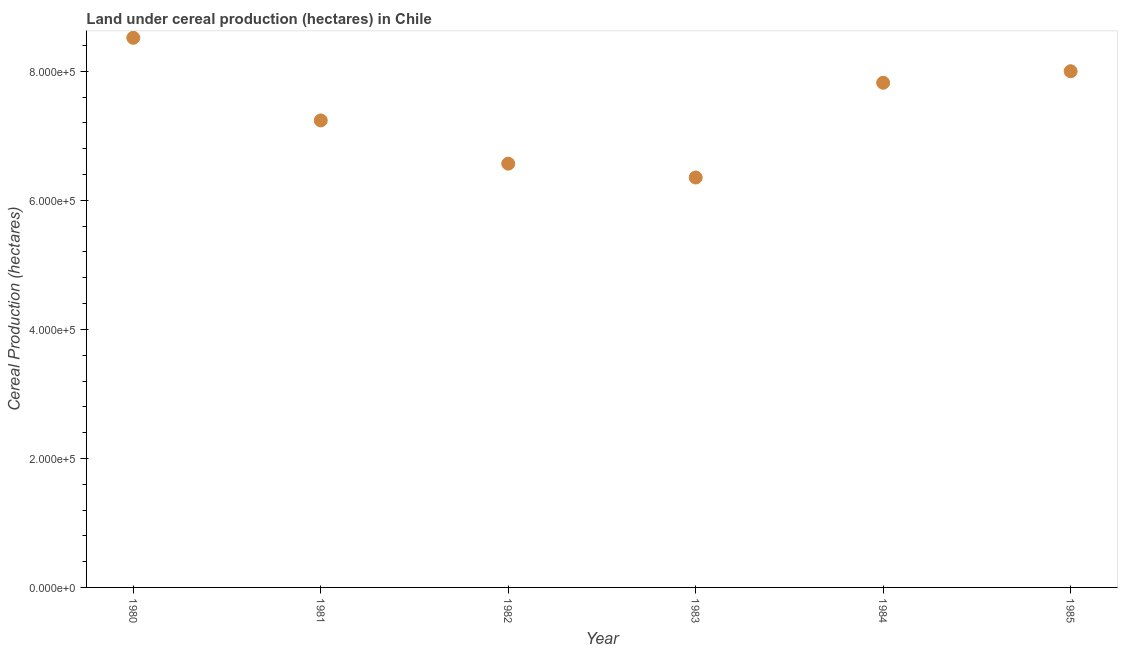What is the land under cereal production in 1985?
Your answer should be very brief. 8.00e+05. Across all years, what is the maximum land under cereal production?
Keep it short and to the point. 8.52e+05. Across all years, what is the minimum land under cereal production?
Offer a terse response. 6.35e+05. In which year was the land under cereal production minimum?
Keep it short and to the point. 1983. What is the sum of the land under cereal production?
Your answer should be very brief. 4.45e+06. What is the difference between the land under cereal production in 1982 and 1983?
Offer a terse response. 2.15e+04. What is the average land under cereal production per year?
Offer a terse response. 7.42e+05. What is the median land under cereal production?
Provide a succinct answer. 7.53e+05. What is the ratio of the land under cereal production in 1984 to that in 1985?
Give a very brief answer. 0.98. Is the land under cereal production in 1984 less than that in 1985?
Give a very brief answer. Yes. What is the difference between the highest and the second highest land under cereal production?
Give a very brief answer. 5.18e+04. What is the difference between the highest and the lowest land under cereal production?
Your answer should be compact. 2.17e+05. In how many years, is the land under cereal production greater than the average land under cereal production taken over all years?
Make the answer very short. 3. Does the land under cereal production monotonically increase over the years?
Your response must be concise. No. How many dotlines are there?
Your response must be concise. 1. How many years are there in the graph?
Make the answer very short. 6. Are the values on the major ticks of Y-axis written in scientific E-notation?
Your response must be concise. Yes. What is the title of the graph?
Make the answer very short. Land under cereal production (hectares) in Chile. What is the label or title of the X-axis?
Offer a very short reply. Year. What is the label or title of the Y-axis?
Your answer should be compact. Cereal Production (hectares). What is the Cereal Production (hectares) in 1980?
Ensure brevity in your answer.  8.52e+05. What is the Cereal Production (hectares) in 1981?
Make the answer very short. 7.24e+05. What is the Cereal Production (hectares) in 1982?
Provide a short and direct response. 6.57e+05. What is the Cereal Production (hectares) in 1983?
Your response must be concise. 6.35e+05. What is the Cereal Production (hectares) in 1984?
Your answer should be compact. 7.82e+05. What is the Cereal Production (hectares) in 1985?
Make the answer very short. 8.00e+05. What is the difference between the Cereal Production (hectares) in 1980 and 1981?
Provide a succinct answer. 1.28e+05. What is the difference between the Cereal Production (hectares) in 1980 and 1982?
Your response must be concise. 1.95e+05. What is the difference between the Cereal Production (hectares) in 1980 and 1983?
Give a very brief answer. 2.17e+05. What is the difference between the Cereal Production (hectares) in 1980 and 1984?
Provide a succinct answer. 6.97e+04. What is the difference between the Cereal Production (hectares) in 1980 and 1985?
Your answer should be compact. 5.18e+04. What is the difference between the Cereal Production (hectares) in 1981 and 1982?
Your response must be concise. 6.70e+04. What is the difference between the Cereal Production (hectares) in 1981 and 1983?
Your response must be concise. 8.85e+04. What is the difference between the Cereal Production (hectares) in 1981 and 1984?
Make the answer very short. -5.84e+04. What is the difference between the Cereal Production (hectares) in 1981 and 1985?
Offer a very short reply. -7.63e+04. What is the difference between the Cereal Production (hectares) in 1982 and 1983?
Your answer should be compact. 2.15e+04. What is the difference between the Cereal Production (hectares) in 1982 and 1984?
Your response must be concise. -1.25e+05. What is the difference between the Cereal Production (hectares) in 1982 and 1985?
Keep it short and to the point. -1.43e+05. What is the difference between the Cereal Production (hectares) in 1983 and 1984?
Offer a very short reply. -1.47e+05. What is the difference between the Cereal Production (hectares) in 1983 and 1985?
Your answer should be very brief. -1.65e+05. What is the difference between the Cereal Production (hectares) in 1984 and 1985?
Your response must be concise. -1.79e+04. What is the ratio of the Cereal Production (hectares) in 1980 to that in 1981?
Keep it short and to the point. 1.18. What is the ratio of the Cereal Production (hectares) in 1980 to that in 1982?
Your answer should be very brief. 1.3. What is the ratio of the Cereal Production (hectares) in 1980 to that in 1983?
Provide a short and direct response. 1.34. What is the ratio of the Cereal Production (hectares) in 1980 to that in 1984?
Ensure brevity in your answer.  1.09. What is the ratio of the Cereal Production (hectares) in 1980 to that in 1985?
Keep it short and to the point. 1.06. What is the ratio of the Cereal Production (hectares) in 1981 to that in 1982?
Keep it short and to the point. 1.1. What is the ratio of the Cereal Production (hectares) in 1981 to that in 1983?
Make the answer very short. 1.14. What is the ratio of the Cereal Production (hectares) in 1981 to that in 1984?
Offer a terse response. 0.93. What is the ratio of the Cereal Production (hectares) in 1981 to that in 1985?
Your response must be concise. 0.91. What is the ratio of the Cereal Production (hectares) in 1982 to that in 1983?
Provide a short and direct response. 1.03. What is the ratio of the Cereal Production (hectares) in 1982 to that in 1984?
Provide a succinct answer. 0.84. What is the ratio of the Cereal Production (hectares) in 1982 to that in 1985?
Provide a short and direct response. 0.82. What is the ratio of the Cereal Production (hectares) in 1983 to that in 1984?
Your answer should be very brief. 0.81. What is the ratio of the Cereal Production (hectares) in 1983 to that in 1985?
Provide a succinct answer. 0.79. 